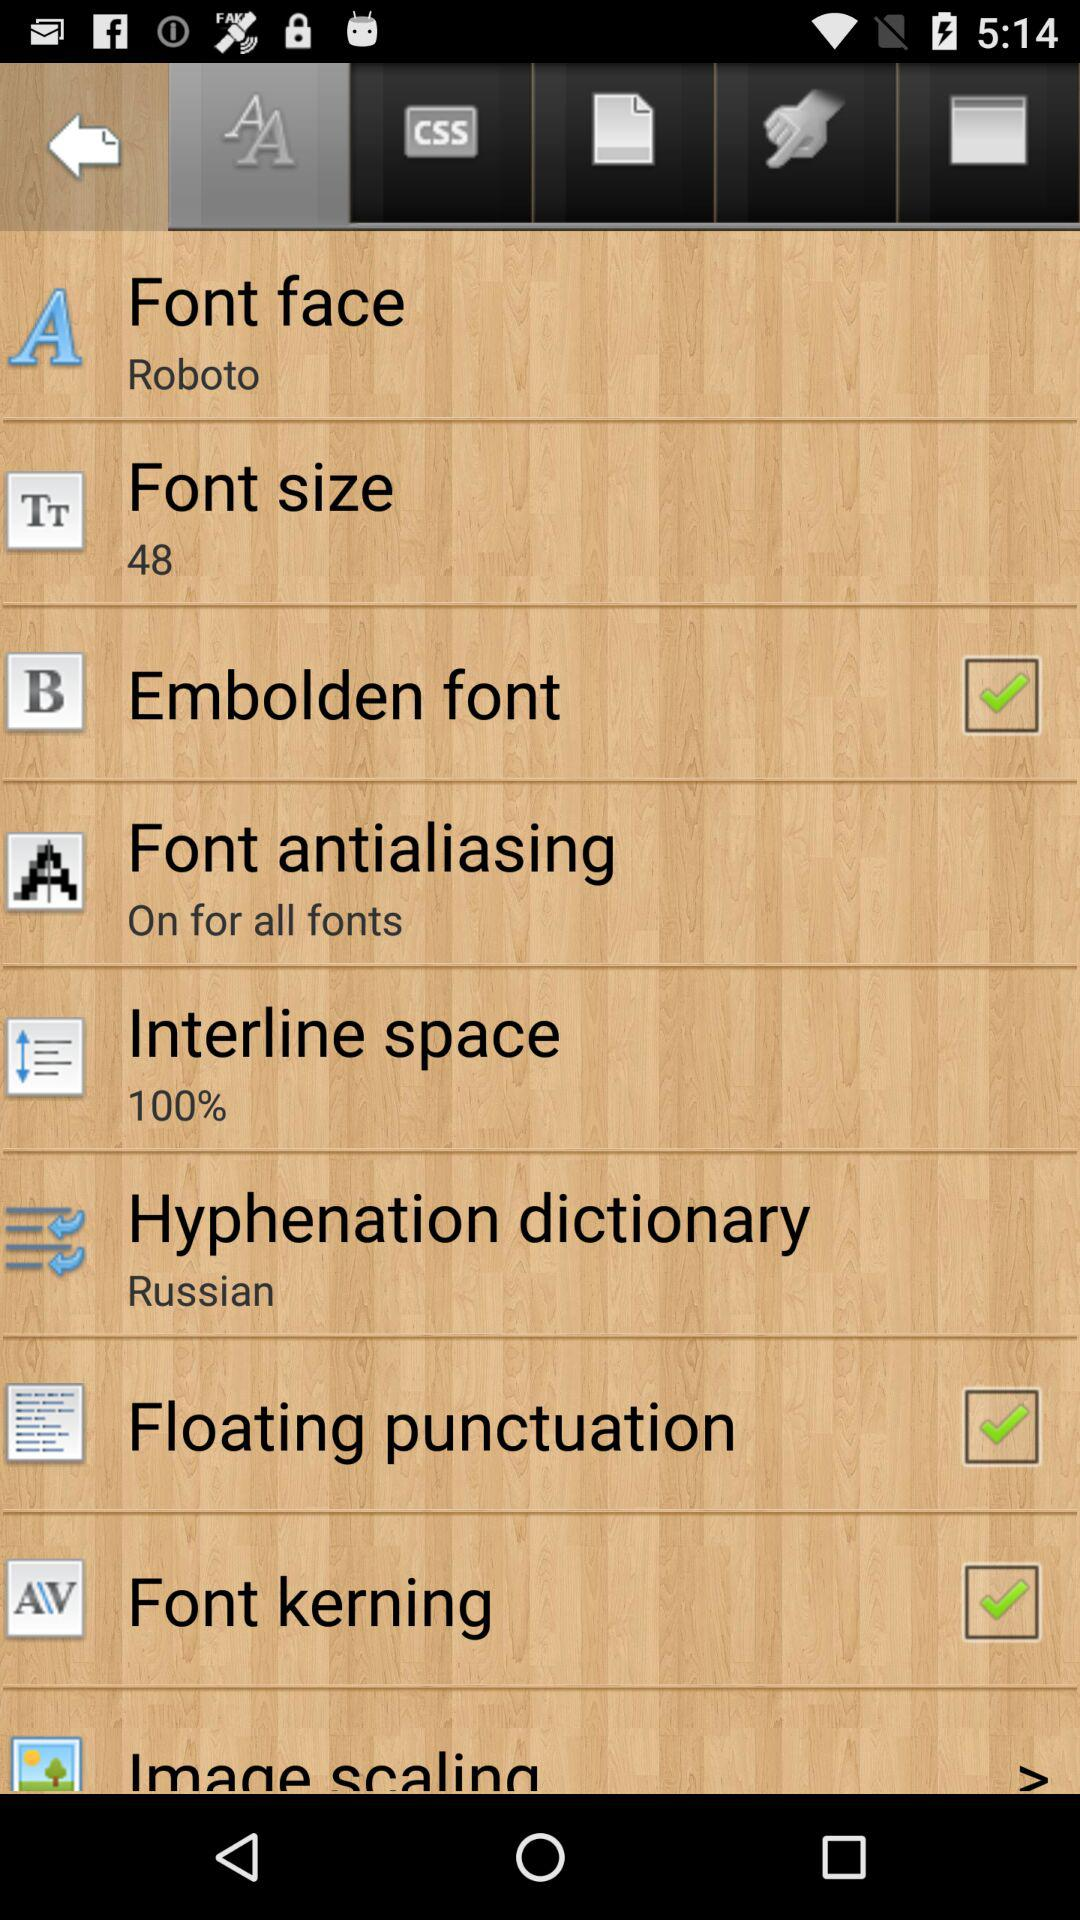What is the status of embolden font? The status is "on". 